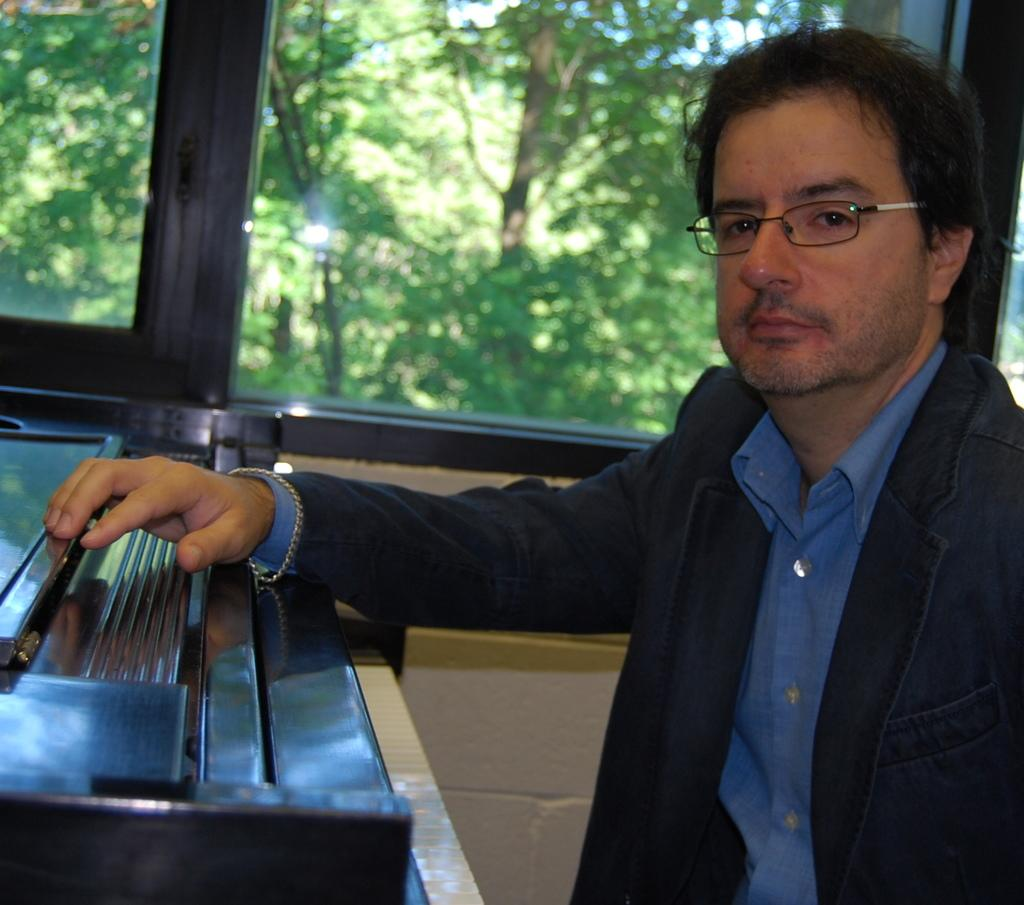Who is present in the image? There is a man in the image. What is the man wearing on his upper body? The man is wearing a coat and a shirt. What accessory is the man wearing on his face? The man is wearing spectacles. What can be seen through the glass in the image? There is a glass window in the image, and trees are visible outside the window. What type of van is parked on the road outside the window? There is no van or road visible in the image; it only shows a man, his clothing, and a window with trees outside. 